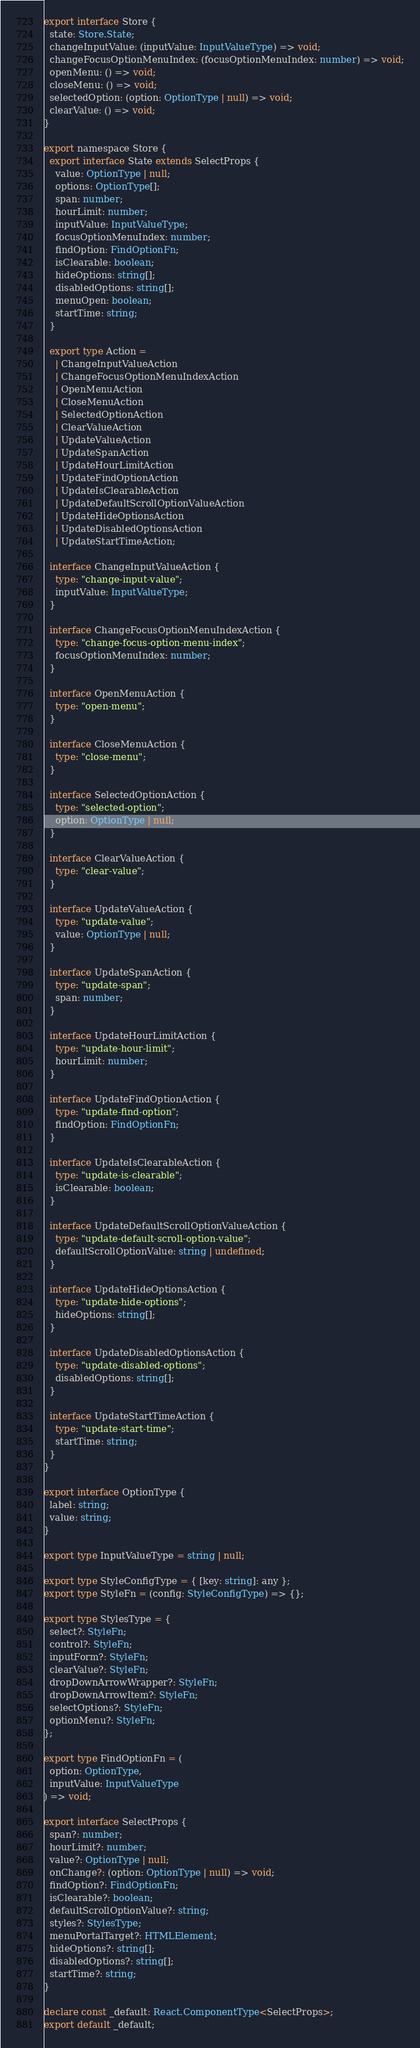Convert code to text. <code><loc_0><loc_0><loc_500><loc_500><_TypeScript_>export interface Store {
  state: Store.State;
  changeInputValue: (inputValue: InputValueType) => void;
  changeFocusOptionMenuIndex: (focusOptionMenuIndex: number) => void;
  openMenu: () => void;
  closeMenu: () => void;
  selectedOption: (option: OptionType | null) => void;
  clearValue: () => void;
}

export namespace Store {
  export interface State extends SelectProps {
    value: OptionType | null;
    options: OptionType[];
    span: number;
    hourLimit: number;
    inputValue: InputValueType;
    focusOptionMenuIndex: number;
    findOption: FindOptionFn;
    isClearable: boolean;
    hideOptions: string[];
    disabledOptions: string[];
    menuOpen: boolean;
    startTime: string;
  }

  export type Action =
    | ChangeInputValueAction
    | ChangeFocusOptionMenuIndexAction
    | OpenMenuAction
    | CloseMenuAction
    | SelectedOptionAction
    | ClearValueAction
    | UpdateValueAction
    | UpdateSpanAction
    | UpdateHourLimitAction
    | UpdateFindOptionAction
    | UpdateIsClearableAction
    | UpdateDefaultScrollOptionValueAction
    | UpdateHideOptionsAction
    | UpdateDisabledOptionsAction
    | UpdateStartTimeAction;

  interface ChangeInputValueAction {
    type: "change-input-value";
    inputValue: InputValueType;
  }

  interface ChangeFocusOptionMenuIndexAction {
    type: "change-focus-option-menu-index";
    focusOptionMenuIndex: number;
  }

  interface OpenMenuAction {
    type: "open-menu";
  }

  interface CloseMenuAction {
    type: "close-menu";
  }

  interface SelectedOptionAction {
    type: "selected-option";
    option: OptionType | null;
  }

  interface ClearValueAction {
    type: "clear-value";
  }

  interface UpdateValueAction {
    type: "update-value";
    value: OptionType | null;
  }

  interface UpdateSpanAction {
    type: "update-span";
    span: number;
  }

  interface UpdateHourLimitAction {
    type: "update-hour-limit";
    hourLimit: number;
  }

  interface UpdateFindOptionAction {
    type: "update-find-option";
    findOption: FindOptionFn;
  }

  interface UpdateIsClearableAction {
    type: "update-is-clearable";
    isClearable: boolean;
  }

  interface UpdateDefaultScrollOptionValueAction {
    type: "update-default-scroll-option-value";
    defaultScrollOptionValue: string | undefined;
  }

  interface UpdateHideOptionsAction {
    type: "update-hide-options";
    hideOptions: string[];
  }

  interface UpdateDisabledOptionsAction {
    type: "update-disabled-options";
    disabledOptions: string[];
  }

  interface UpdateStartTimeAction {
    type: "update-start-time";
    startTime: string;
  }
}

export interface OptionType {
  label: string;
  value: string;
}

export type InputValueType = string | null;

export type StyleConfigType = { [key: string]: any };
export type StyleFn = (config: StyleConfigType) => {};

export type StylesType = {
  select?: StyleFn;
  control?: StyleFn;
  inputForm?: StyleFn;
  clearValue?: StyleFn;
  dropDownArrowWrapper?: StyleFn;
  dropDownArrowItem?: StyleFn;
  selectOptions?: StyleFn;
  optionMenu?: StyleFn;
};

export type FindOptionFn = (
  option: OptionType,
  inputValue: InputValueType
) => void;

export interface SelectProps {
  span?: number;
  hourLimit?: number;
  value?: OptionType | null;
  onChange?: (option: OptionType | null) => void;
  findOption?: FindOptionFn;
  isClearable?: boolean;
  defaultScrollOptionValue?: string;
  styles?: StylesType;
  menuPortalTarget?: HTMLElement;
  hideOptions?: string[];
  disabledOptions?: string[];
  startTime?: string;
}

declare const _default: React.ComponentType<SelectProps>;
export default _default;
</code> 